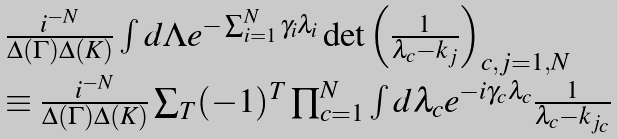Convert formula to latex. <formula><loc_0><loc_0><loc_500><loc_500>\begin{array} { l } \frac { i ^ { - N } } { \Delta ( \Gamma ) \Delta ( K ) } \int d \Lambda e ^ { - \sum _ { i = 1 } ^ { N } \gamma _ { i } \lambda _ { i } } \det { \left ( \frac { 1 } { \lambda _ { c } - k _ { j } } \right ) } _ { c , j = 1 , N } \\ \equiv \frac { i ^ { - N } } { \Delta ( \Gamma ) \Delta ( K ) } \sum _ { T } ( - 1 ) ^ { T } \prod _ { c = 1 } ^ { N } \int d \lambda _ { c } e ^ { - i \gamma _ { c } \lambda _ { c } } \frac { 1 } { \lambda _ { c } - k _ { j _ { c } } } \end{array}</formula> 